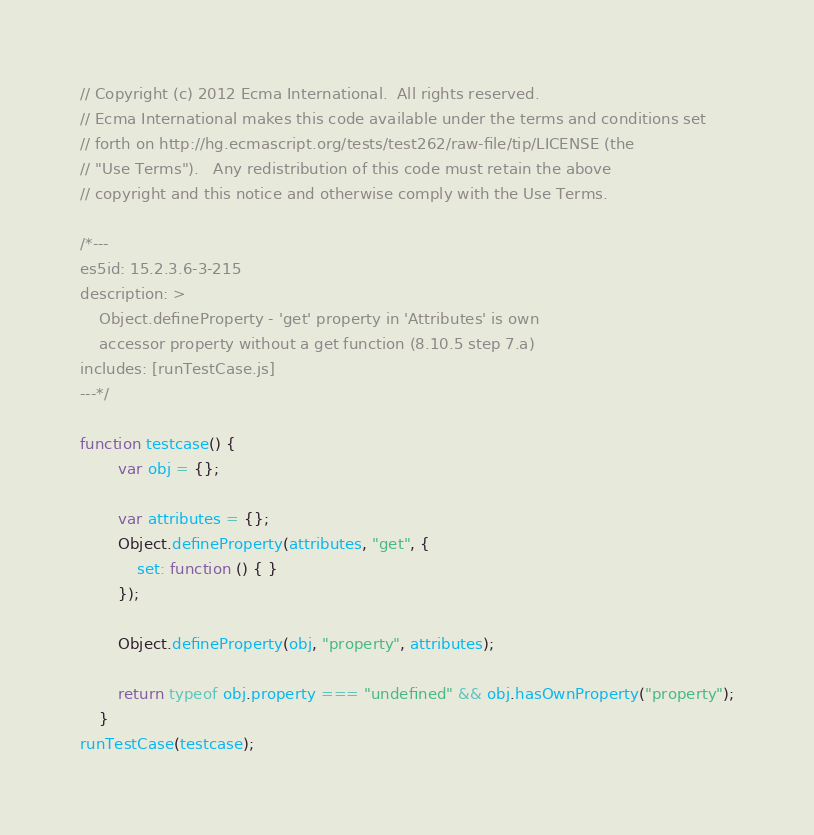Convert code to text. <code><loc_0><loc_0><loc_500><loc_500><_JavaScript_>// Copyright (c) 2012 Ecma International.  All rights reserved.
// Ecma International makes this code available under the terms and conditions set
// forth on http://hg.ecmascript.org/tests/test262/raw-file/tip/LICENSE (the
// "Use Terms").   Any redistribution of this code must retain the above
// copyright and this notice and otherwise comply with the Use Terms.

/*---
es5id: 15.2.3.6-3-215
description: >
    Object.defineProperty - 'get' property in 'Attributes' is own
    accessor property without a get function (8.10.5 step 7.a)
includes: [runTestCase.js]
---*/

function testcase() {
        var obj = {};

        var attributes = {};
        Object.defineProperty(attributes, "get", {
            set: function () { }
        });

        Object.defineProperty(obj, "property", attributes);

        return typeof obj.property === "undefined" && obj.hasOwnProperty("property");
    }
runTestCase(testcase);
</code> 